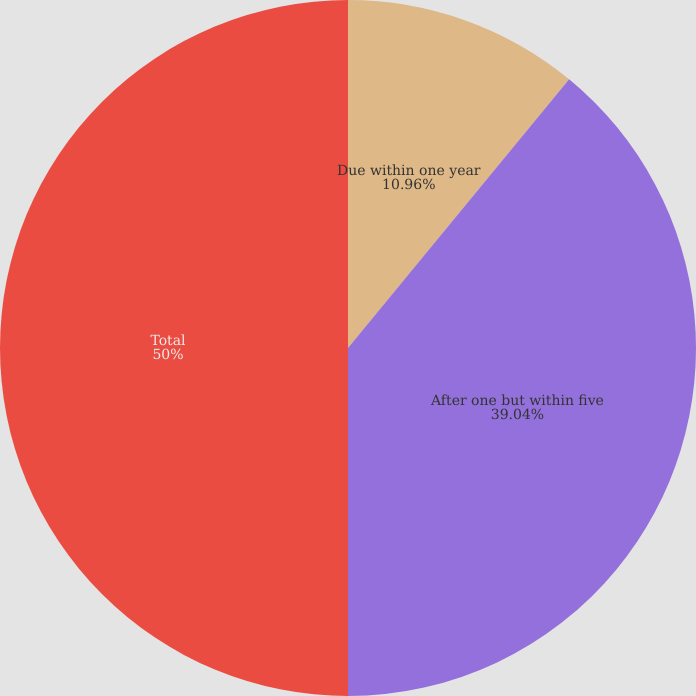Convert chart to OTSL. <chart><loc_0><loc_0><loc_500><loc_500><pie_chart><fcel>Due within one year<fcel>After one but within five<fcel>Total<nl><fcel>10.96%<fcel>39.04%<fcel>50.0%<nl></chart> 